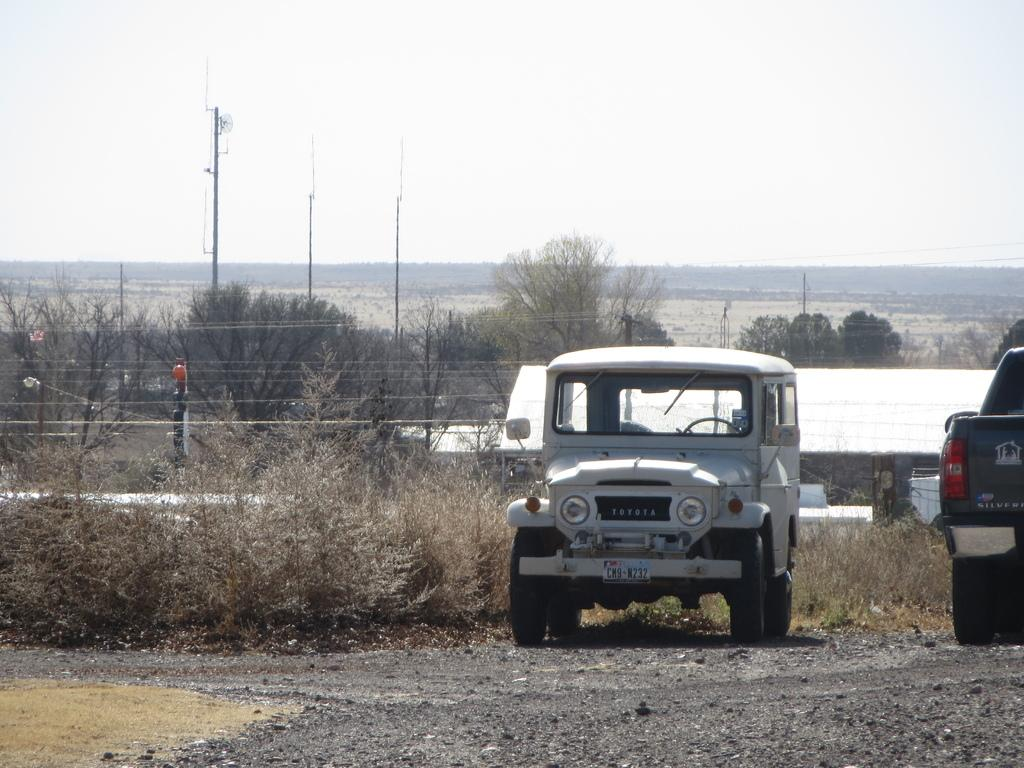What type of vehicle is in the image? There is a jeep in the image. What color is the jeep? The jeep is white. Are there any other vehicles in the image? Yes, there is another vehicle in the image. Where are the vehicles located in the image? The vehicles are on the right side of the image. What can be seen in the middle of the image? There are trees in the middle of the image. What is visible at the top of the image? The sky is visible at the top of the image. What type of shoe is hanging from the tree in the image? There is no shoe hanging from the tree in the image; only trees are present in the middle of the image. What is the desire of the lettuce in the image? There is no lettuce present in the image, so it cannot have any desires. 